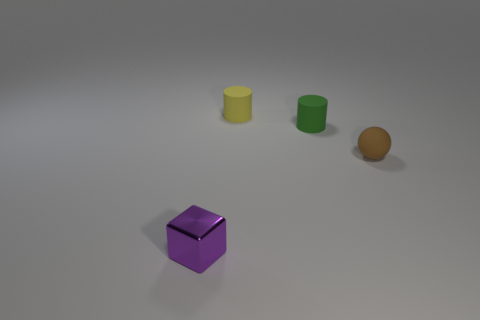Are the small purple block and the cylinder to the right of the small yellow matte object made of the same material?
Give a very brief answer. No. There is a tiny matte object behind the tiny green object; what shape is it?
Make the answer very short. Cylinder. The tiny sphere that is made of the same material as the small green thing is what color?
Make the answer very short. Brown. There is a thing that is on the left side of the brown ball and in front of the green thing; what color is it?
Provide a succinct answer. Purple. Are there any small objects that are in front of the thing that is in front of the small matte sphere?
Keep it short and to the point. No. There is a small cylinder that is in front of the yellow cylinder; what is its color?
Offer a very short reply. Green. There is a tiny object that is both behind the purple metal thing and in front of the tiny green matte thing; what shape is it?
Give a very brief answer. Sphere. The other small thing that is the same shape as the green rubber thing is what color?
Offer a very short reply. Yellow. There is a small object to the left of the tiny rubber cylinder left of the tiny cylinder to the right of the yellow cylinder; what is its shape?
Your answer should be very brief. Cube. There is a cylinder that is in front of the small rubber thing that is to the left of the small green rubber object; what number of tiny green matte things are behind it?
Your answer should be compact. 0. 